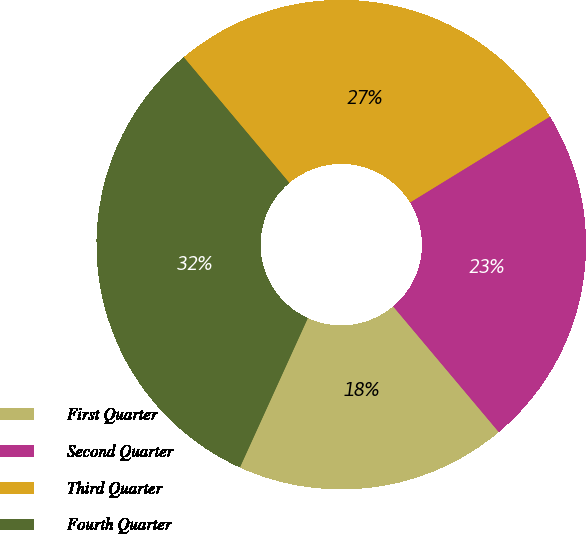Convert chart. <chart><loc_0><loc_0><loc_500><loc_500><pie_chart><fcel>First Quarter<fcel>Second Quarter<fcel>Third Quarter<fcel>Fourth Quarter<nl><fcel>17.92%<fcel>22.64%<fcel>27.36%<fcel>32.08%<nl></chart> 